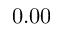<formula> <loc_0><loc_0><loc_500><loc_500>0 . 0 0</formula> 